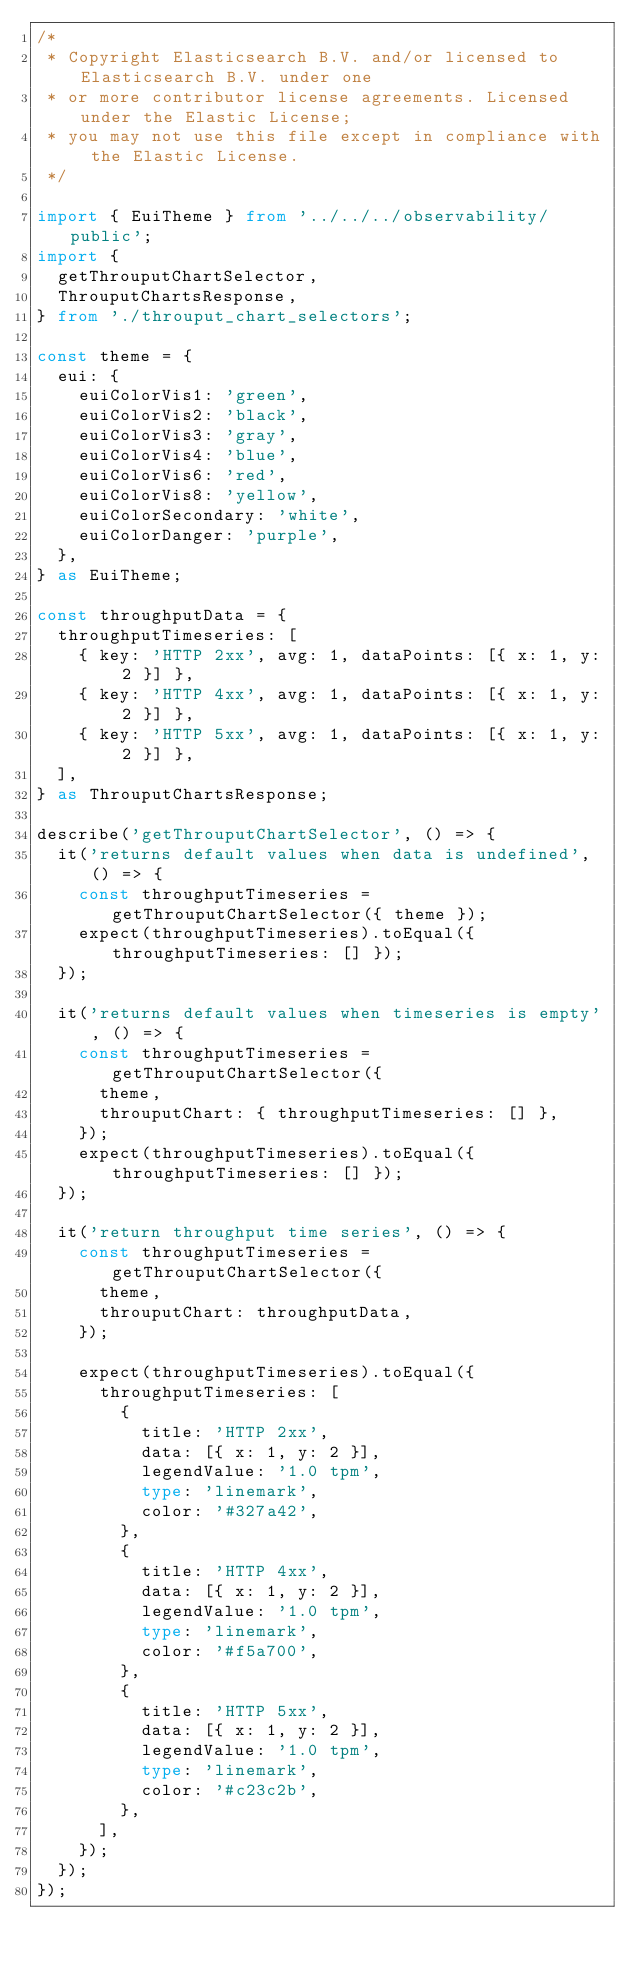<code> <loc_0><loc_0><loc_500><loc_500><_TypeScript_>/*
 * Copyright Elasticsearch B.V. and/or licensed to Elasticsearch B.V. under one
 * or more contributor license agreements. Licensed under the Elastic License;
 * you may not use this file except in compliance with the Elastic License.
 */

import { EuiTheme } from '../../../observability/public';
import {
  getThrouputChartSelector,
  ThrouputChartsResponse,
} from './throuput_chart_selectors';

const theme = {
  eui: {
    euiColorVis1: 'green',
    euiColorVis2: 'black',
    euiColorVis3: 'gray',
    euiColorVis4: 'blue',
    euiColorVis6: 'red',
    euiColorVis8: 'yellow',
    euiColorSecondary: 'white',
    euiColorDanger: 'purple',
  },
} as EuiTheme;

const throughputData = {
  throughputTimeseries: [
    { key: 'HTTP 2xx', avg: 1, dataPoints: [{ x: 1, y: 2 }] },
    { key: 'HTTP 4xx', avg: 1, dataPoints: [{ x: 1, y: 2 }] },
    { key: 'HTTP 5xx', avg: 1, dataPoints: [{ x: 1, y: 2 }] },
  ],
} as ThrouputChartsResponse;

describe('getThrouputChartSelector', () => {
  it('returns default values when data is undefined', () => {
    const throughputTimeseries = getThrouputChartSelector({ theme });
    expect(throughputTimeseries).toEqual({ throughputTimeseries: [] });
  });

  it('returns default values when timeseries is empty', () => {
    const throughputTimeseries = getThrouputChartSelector({
      theme,
      throuputChart: { throughputTimeseries: [] },
    });
    expect(throughputTimeseries).toEqual({ throughputTimeseries: [] });
  });

  it('return throughput time series', () => {
    const throughputTimeseries = getThrouputChartSelector({
      theme,
      throuputChart: throughputData,
    });

    expect(throughputTimeseries).toEqual({
      throughputTimeseries: [
        {
          title: 'HTTP 2xx',
          data: [{ x: 1, y: 2 }],
          legendValue: '1.0 tpm',
          type: 'linemark',
          color: '#327a42',
        },
        {
          title: 'HTTP 4xx',
          data: [{ x: 1, y: 2 }],
          legendValue: '1.0 tpm',
          type: 'linemark',
          color: '#f5a700',
        },
        {
          title: 'HTTP 5xx',
          data: [{ x: 1, y: 2 }],
          legendValue: '1.0 tpm',
          type: 'linemark',
          color: '#c23c2b',
        },
      ],
    });
  });
});
</code> 